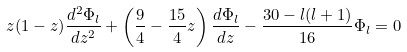<formula> <loc_0><loc_0><loc_500><loc_500>z ( 1 - z ) \frac { d ^ { 2 } \Phi _ { l } } { d z ^ { 2 } } + \left ( \frac { 9 } { 4 } - \frac { 1 5 } { 4 } z \right ) \frac { d \Phi _ { l } } { d z } - \frac { 3 0 - l ( l + 1 ) } { 1 6 } \Phi _ { l } = 0</formula> 